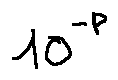Convert formula to latex. <formula><loc_0><loc_0><loc_500><loc_500>1 0 ^ { - p }</formula> 